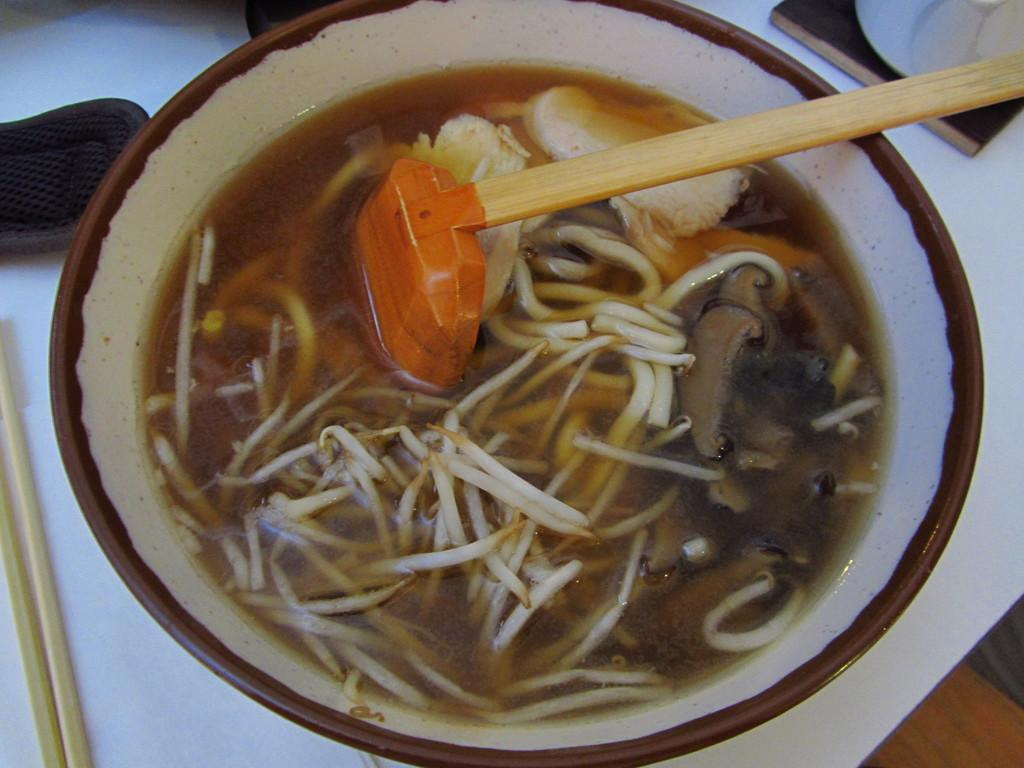What is present in the image that can be used for eating? There is a spoon in the image that can be used for eating. What is the primary purpose of the bowl in the image? The bowl in the image is used to hold eatables. What utensil is located on the left side of the image? There are chopsticks on the left side of the image. What type of ink can be seen in the image? There is no ink present in the image. How does the spoon help the eatables provide an answer? The spoon does not provide an answer; it is used for eating the eatables in the bowl. 